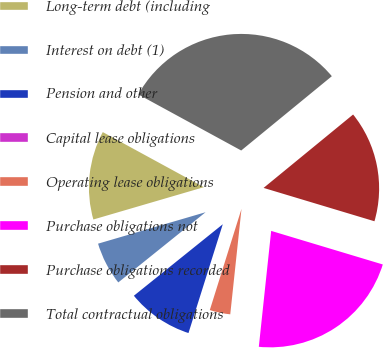Convert chart to OTSL. <chart><loc_0><loc_0><loc_500><loc_500><pie_chart><fcel>Long-term debt (including<fcel>Interest on debt (1)<fcel>Pension and other<fcel>Capital lease obligations<fcel>Operating lease obligations<fcel>Purchase obligations not<fcel>Purchase obligations recorded<fcel>Total contractual obligations<nl><fcel>12.47%<fcel>6.25%<fcel>9.36%<fcel>0.03%<fcel>3.14%<fcel>22.04%<fcel>15.58%<fcel>31.13%<nl></chart> 